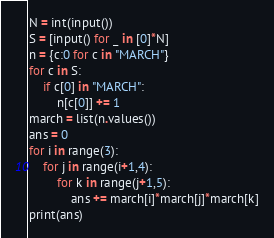Convert code to text. <code><loc_0><loc_0><loc_500><loc_500><_Python_>N = int(input())
S = [input() for _ in [0]*N]
n = {c:0 for c in "MARCH"}
for c in S:
    if c[0] in "MARCH":
        n[c[0]] += 1
march = list(n.values())
ans = 0
for i in range(3):
    for j in range(i+1,4):
        for k in range(j+1,5):
            ans += march[i]*march[j]*march[k]
print(ans)</code> 